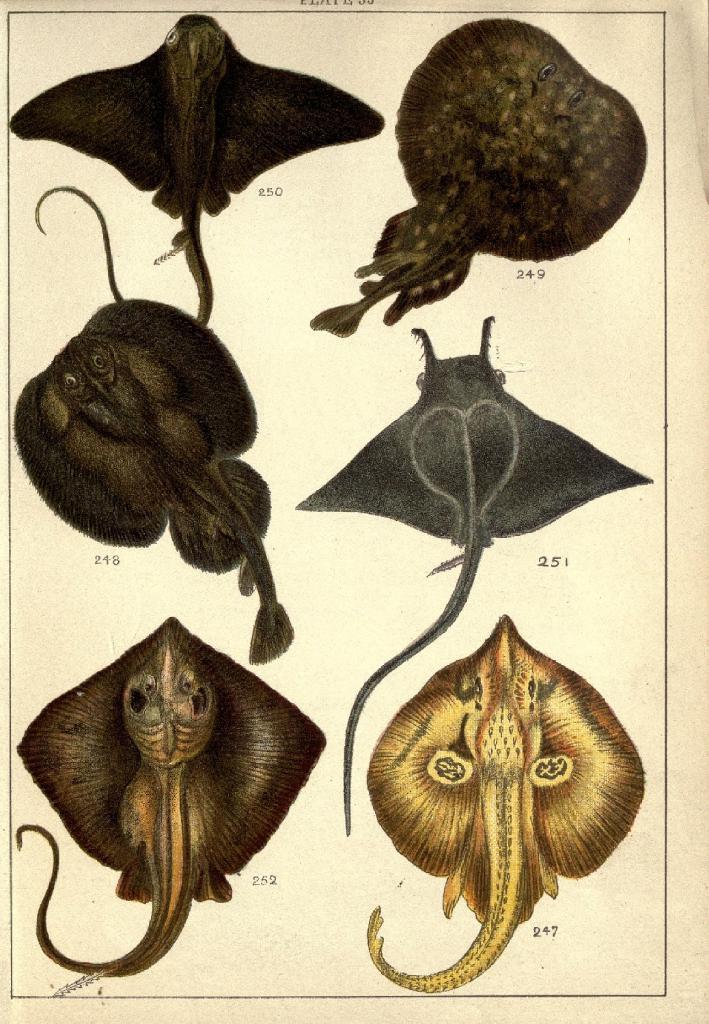Please provide a concise description of this image. In this image we can see pictures of reptiles on the paper. 